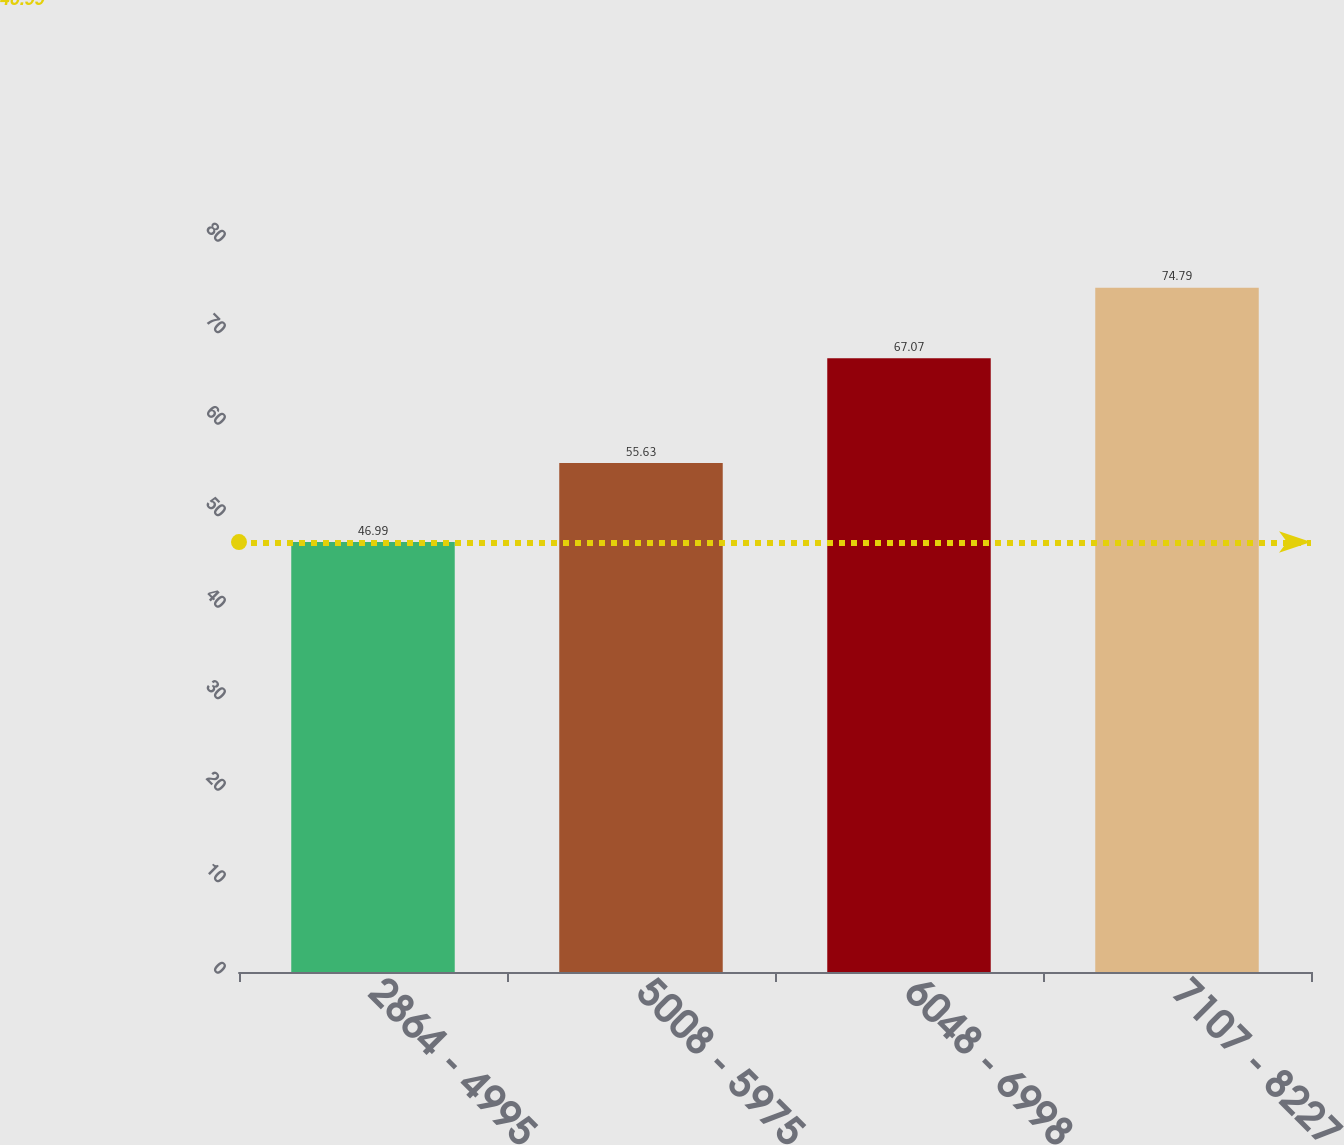Convert chart. <chart><loc_0><loc_0><loc_500><loc_500><bar_chart><fcel>2864 - 4995<fcel>5008 - 5975<fcel>6048 - 6998<fcel>7107 - 8227<nl><fcel>46.99<fcel>55.63<fcel>67.07<fcel>74.79<nl></chart> 